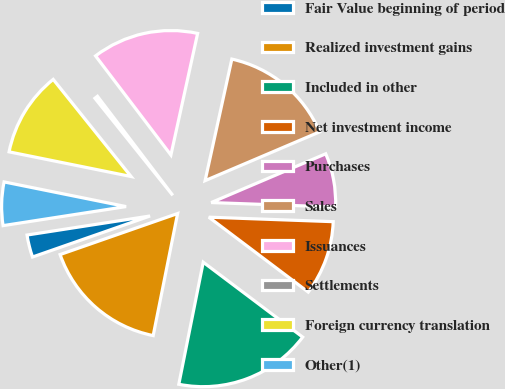Convert chart. <chart><loc_0><loc_0><loc_500><loc_500><pie_chart><fcel>Fair Value beginning of period<fcel>Realized investment gains<fcel>Included in other<fcel>Net investment income<fcel>Purchases<fcel>Sales<fcel>Issuances<fcel>Settlements<fcel>Foreign currency translation<fcel>Other(1)<nl><fcel>2.9%<fcel>16.51%<fcel>17.87%<fcel>9.7%<fcel>6.98%<fcel>15.15%<fcel>13.79%<fcel>0.41%<fcel>11.07%<fcel>5.62%<nl></chart> 